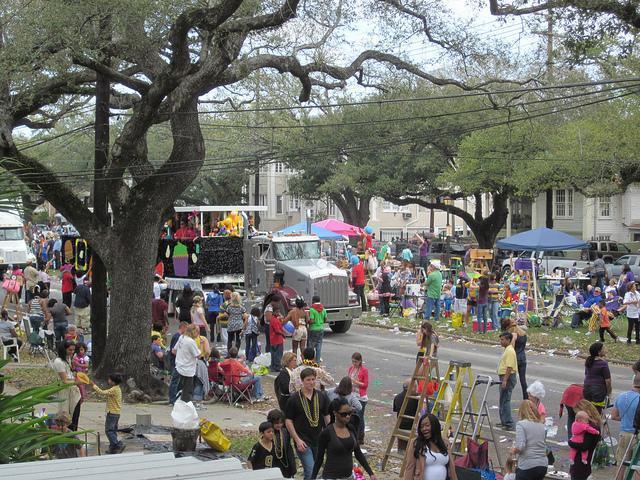How many ladders are there?
Give a very brief answer. 3. How many people are in the picture?
Give a very brief answer. 4. 